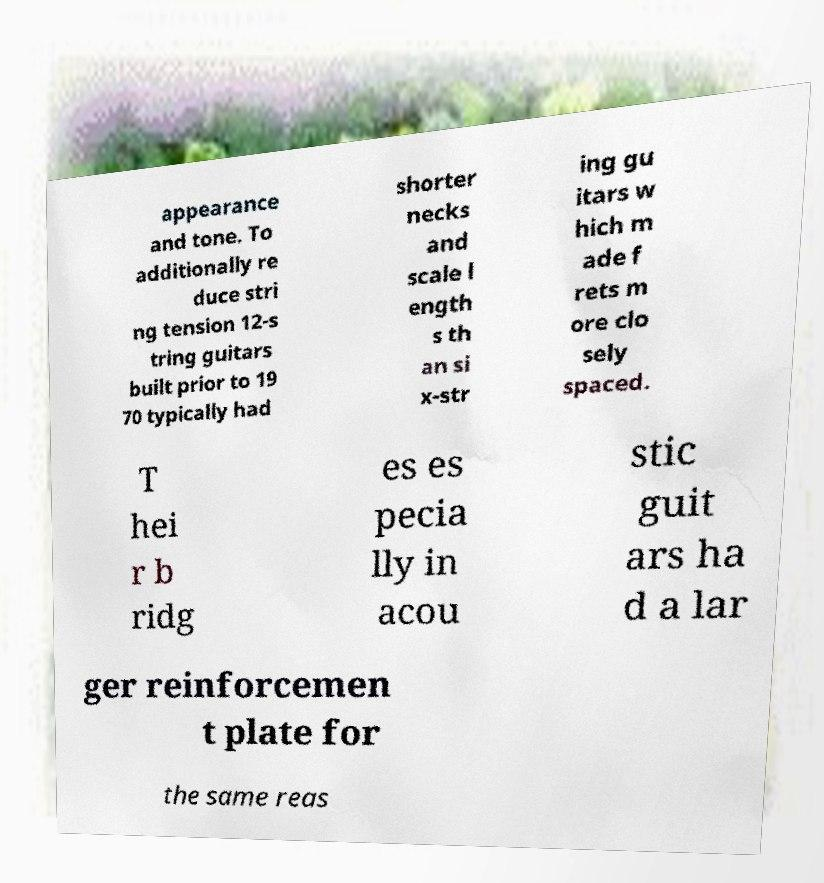For documentation purposes, I need the text within this image transcribed. Could you provide that? appearance and tone. To additionally re duce stri ng tension 12-s tring guitars built prior to 19 70 typically had shorter necks and scale l ength s th an si x-str ing gu itars w hich m ade f rets m ore clo sely spaced. T hei r b ridg es es pecia lly in acou stic guit ars ha d a lar ger reinforcemen t plate for the same reas 